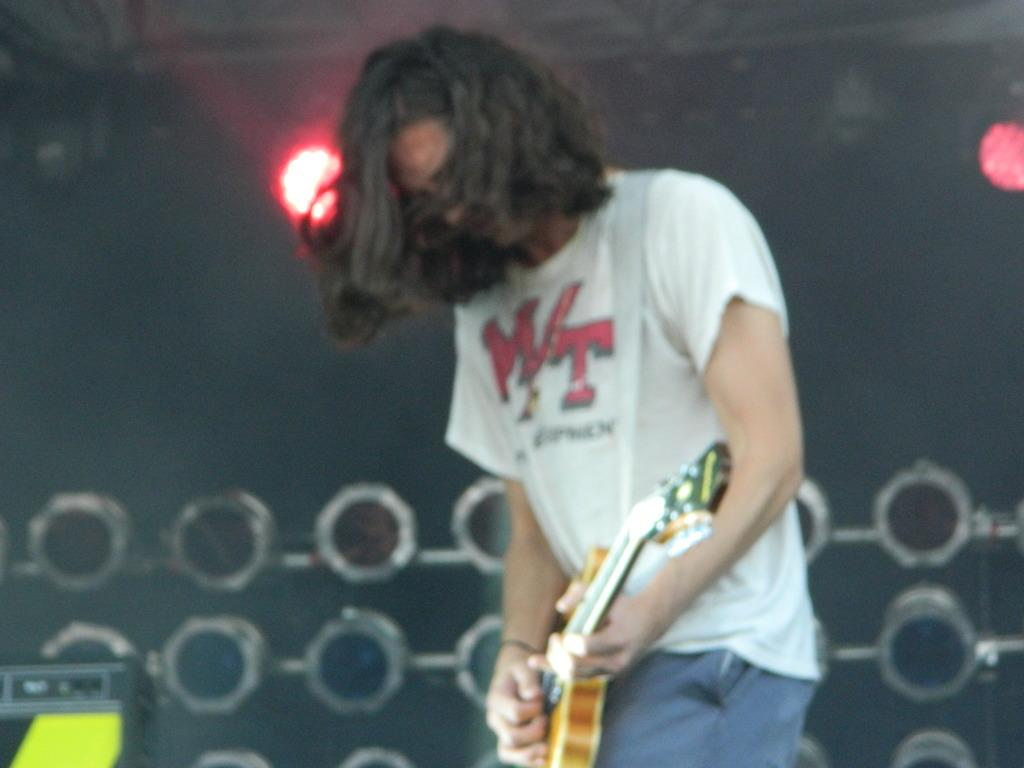What is the main subject of the image? There is a person in the image. What is the person doing in the image? The person is standing and playing a guitar. What can be seen in the background of the image? There are lights visible in the background of the image. What type of test is being conducted in the image? There is no test being conducted in the image; it features a person playing a guitar. What does the person in the image regret? There is no indication of regret in the image; it simply shows a person playing a guitar. 